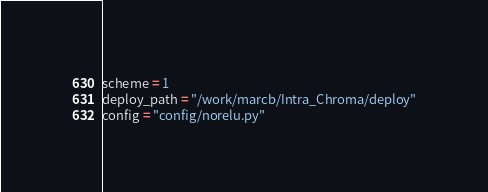Convert code to text. <code><loc_0><loc_0><loc_500><loc_500><_Python_>scheme = 1
deploy_path = "/work/marcb/Intra_Chroma/deploy"
config = "config/norelu.py"
</code> 